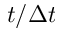Convert formula to latex. <formula><loc_0><loc_0><loc_500><loc_500>t / \Delta t</formula> 